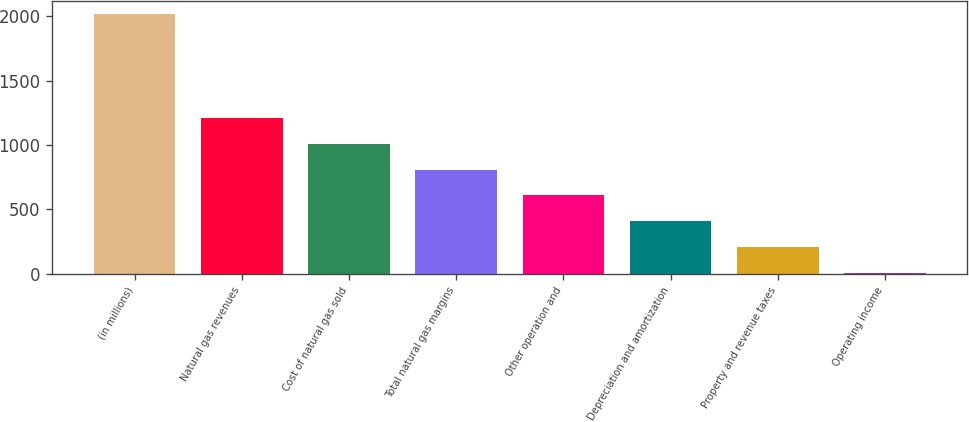Convert chart to OTSL. <chart><loc_0><loc_0><loc_500><loc_500><bar_chart><fcel>(in millions)<fcel>Natural gas revenues<fcel>Cost of natural gas sold<fcel>Total natural gas margins<fcel>Other operation and<fcel>Depreciation and amortization<fcel>Property and revenue taxes<fcel>Operating income<nl><fcel>2015<fcel>1211.4<fcel>1010.5<fcel>809.6<fcel>608.7<fcel>407.8<fcel>206.9<fcel>6<nl></chart> 